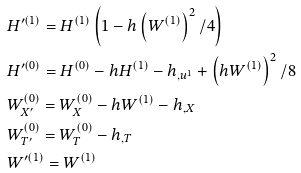Convert formula to latex. <formula><loc_0><loc_0><loc_500><loc_500>& H ^ { \prime ( 1 ) } = H ^ { ( 1 ) } \left ( 1 - h \left ( W ^ { ( 1 ) } \right ) ^ { 2 } / 4 \right ) \\ & H ^ { \prime ( 0 ) } = H ^ { ( 0 ) } - h H ^ { ( 1 ) } - h _ { , u ^ { 1 } } + \left ( h W ^ { ( 1 ) } \right ) ^ { 2 } / 8 \\ & W _ { X ^ { \prime } } ^ { ( 0 ) } = W _ { X } ^ { ( 0 ) } - h W ^ { ( 1 ) } - h _ { , X } \\ & W _ { T ^ { \prime } } ^ { ( 0 ) } = W _ { T } ^ { ( 0 ) } - h _ { , T } \\ & W ^ { \prime ( 1 ) } = W ^ { ( 1 ) }</formula> 